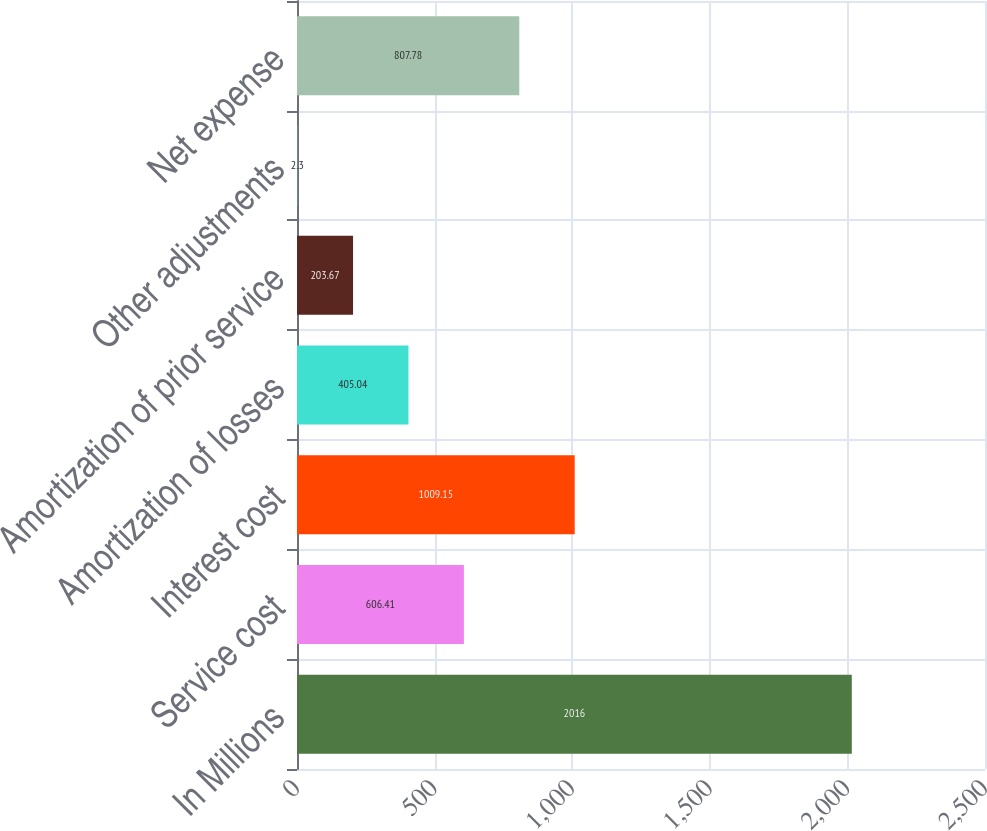Convert chart to OTSL. <chart><loc_0><loc_0><loc_500><loc_500><bar_chart><fcel>In Millions<fcel>Service cost<fcel>Interest cost<fcel>Amortization of losses<fcel>Amortization of prior service<fcel>Other adjustments<fcel>Net expense<nl><fcel>2016<fcel>606.41<fcel>1009.15<fcel>405.04<fcel>203.67<fcel>2.3<fcel>807.78<nl></chart> 